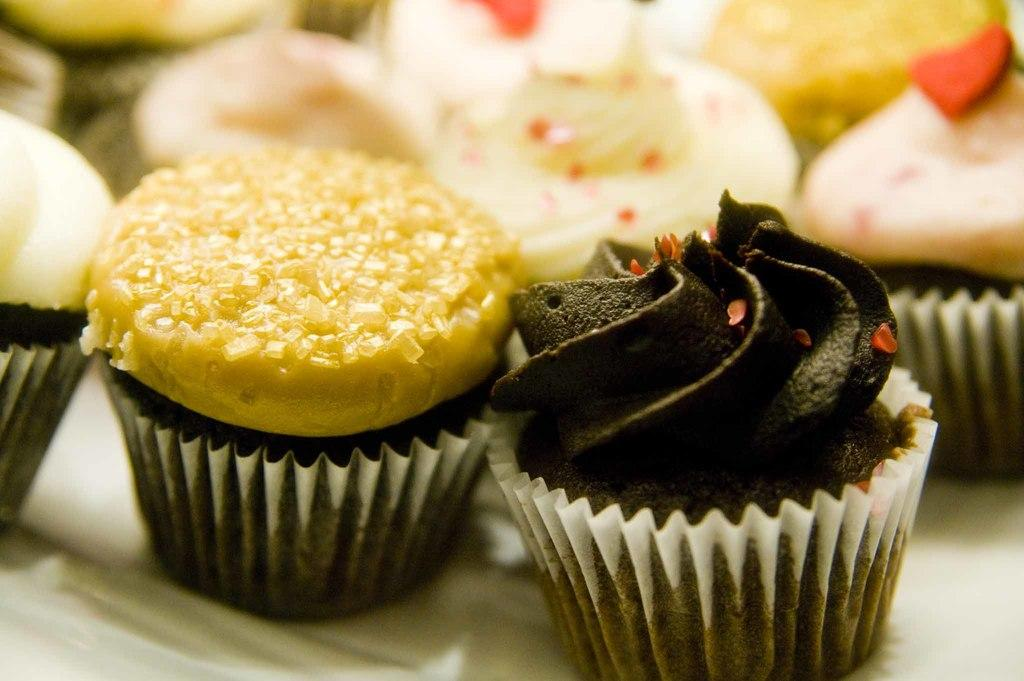What type of food is present in the image? There are cupcakes in the image. Can you describe the background of the image? The background of the image is blurry. What type of drum is featured in the background of the image? There is no drum present in the image; the background is blurry. 